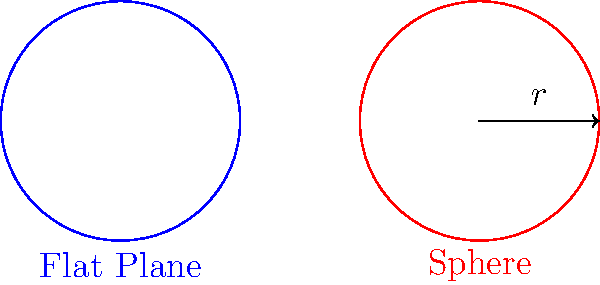As a data analyst for a news agency, you're working on a story about the differences between Euclidean and non-Euclidean geometry. You need to compare the area of a circle with radius $r$ on a flat plane versus the surface area of the same circle on a sphere with radius $R$, where $r \ll R$. If the radius of the circle is 100 km and the radius of the Earth is approximately 6,371 km, what is the percentage difference between the two areas? To solve this problem, we need to follow these steps:

1. Calculate the area of the circle on a flat plane:
   $$A_{flat} = \pi r^2$$

2. Calculate the area of the circle on a sphere (spherical cap):
   $$A_{sphere} = 2\pi R h$$
   where $h$ is the height of the spherical cap.

3. Find $h$ using the Pythagorean theorem:
   $$R^2 = (R-h)^2 + r^2$$
   $$R^2 = R^2 - 2Rh + h^2 + r^2$$
   $$2Rh - h^2 = r^2$$
   Since $r \ll R$, we can approximate $h^2 \approx 0$:
   $$h \approx \frac{r^2}{2R}$$

4. Substitute the values:
   $r = 100$ km
   $R = 6,371$ km

5. Calculate $A_{flat}$:
   $$A_{flat} = \pi (100)^2 = 31,415.93$ km²

6. Calculate $A_{sphere}$:
   $$h \approx \frac{(100)^2}{2(6,371)} = 0.7848$ km
   $$A_{sphere} = 2\pi(6,371)(0.7848) = 31,405.40$ km²

7. Calculate the percentage difference:
   $$\text{Difference} = \frac{A_{flat} - A_{sphere}}{A_{flat}} \times 100\%$$
   $$= \frac{31,415.93 - 31,405.40}{31,415.93} \times 100\% = 0.0335\%$$

The area on the sphere is slightly smaller due to the curvature of the Earth's surface.
Answer: 0.0335% 